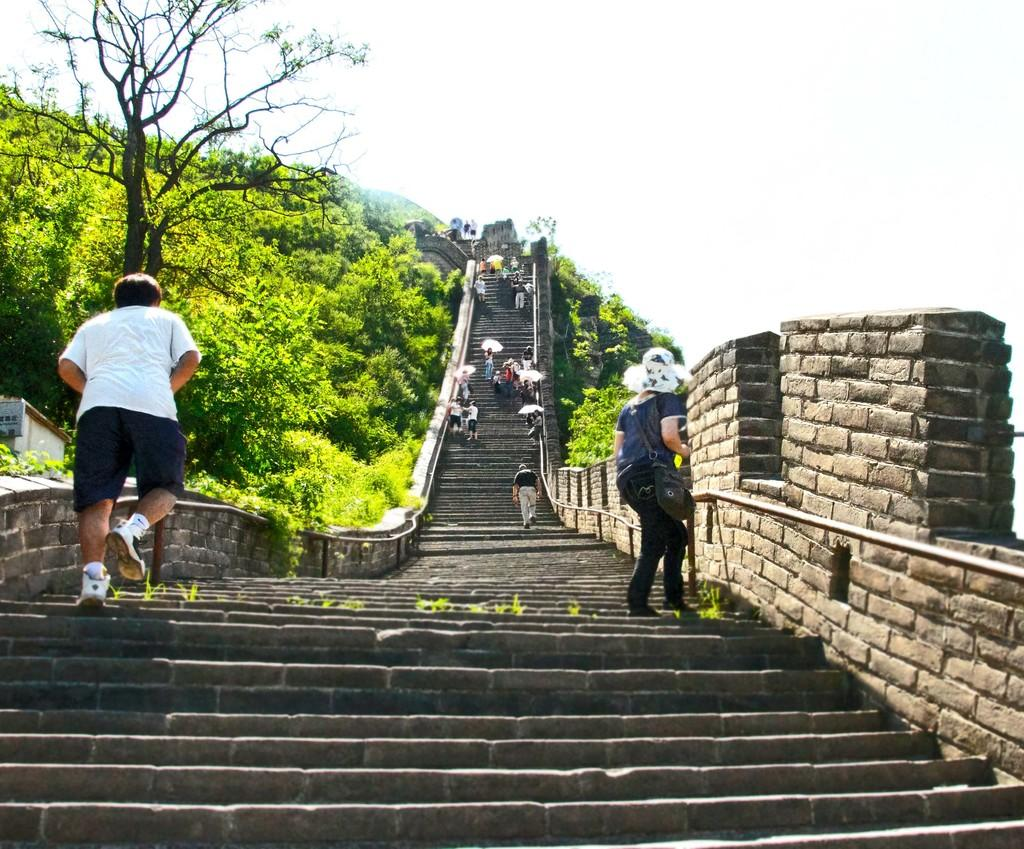How many people are in the image? There is a group of people in the image, but the exact number cannot be determined from the provided facts. Where are the people located in the image? The people are on steps in the image. What can be seen in the background of the image? There is a shed, trees, and the sky visible in the background of the image. Can you see any cobwebs on the shed in the image? There is no mention of cobwebs in the provided facts, so we cannot determine if any are present in the image. 